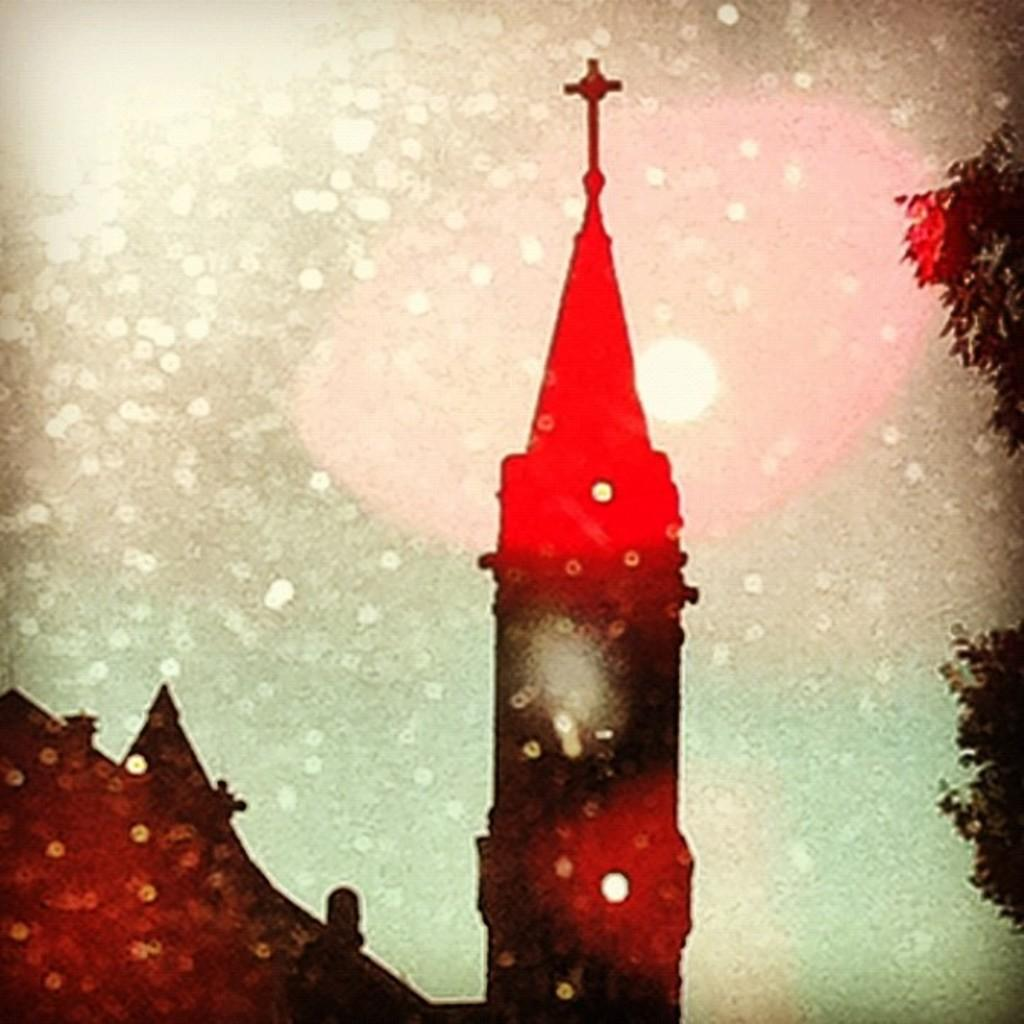What type of structure is present in the image? There is a tower in the image. What other type of structure is present in the image? There is a house in the image. What type of natural elements can be seen in the image? There are trees in the image. What type of artificial elements can be seen in the image? There are lights in the image. Where is the mom in the image? There is no mom present in the image. Can you see any frogs in the image? There are no frogs present in the image. 